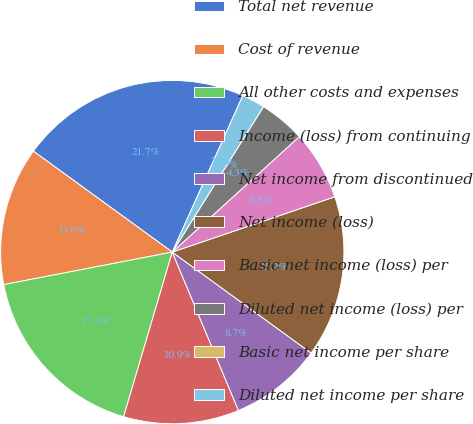Convert chart to OTSL. <chart><loc_0><loc_0><loc_500><loc_500><pie_chart><fcel>Total net revenue<fcel>Cost of revenue<fcel>All other costs and expenses<fcel>Income (loss) from continuing<fcel>Net income from discontinued<fcel>Net income (loss)<fcel>Basic net income (loss) per<fcel>Diluted net income (loss) per<fcel>Basic net income per share<fcel>Diluted net income per share<nl><fcel>21.74%<fcel>13.04%<fcel>17.39%<fcel>10.87%<fcel>8.7%<fcel>15.22%<fcel>6.52%<fcel>4.35%<fcel>0.0%<fcel>2.17%<nl></chart> 